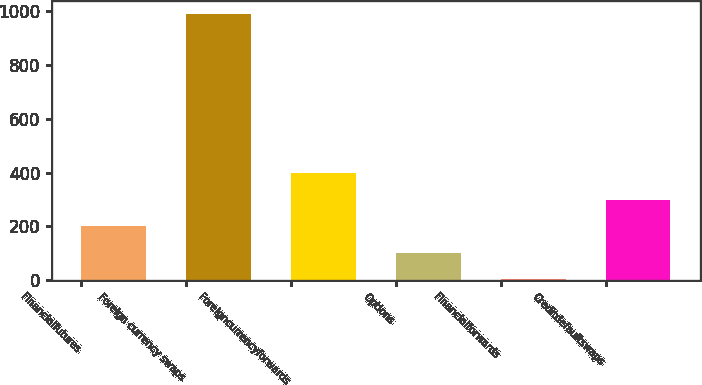<chart> <loc_0><loc_0><loc_500><loc_500><bar_chart><fcel>Financialfutures<fcel>Foreign currency swaps<fcel>Foreigncurrencyforwards<fcel>Options<fcel>Financialforwards<fcel>Creditdefaultswaps<nl><fcel>201.4<fcel>991<fcel>398.8<fcel>102.7<fcel>4<fcel>300.1<nl></chart> 